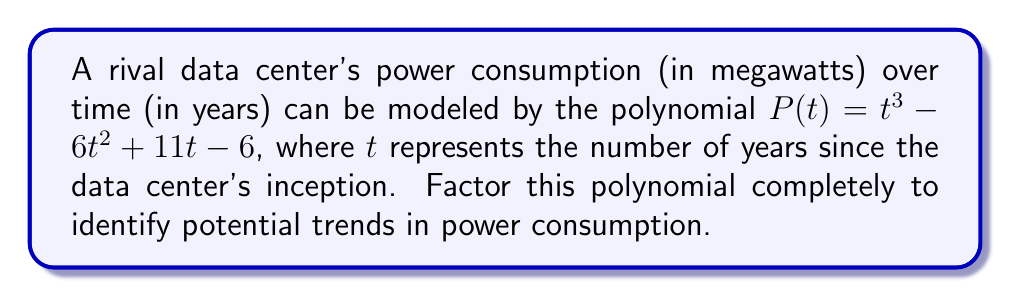Give your solution to this math problem. To factor this polynomial, we'll follow these steps:

1) First, let's check if there's a common factor. In this case, there isn't.

2) Next, we'll try to guess a rational root. The possible rational roots are the factors of the constant term: ±1, ±2, ±3, ±6.

3) Testing these values, we find that $P(1) = 0$. So $(t-1)$ is a factor.

4) We can use polynomial long division to divide $P(t)$ by $(t-1)$:

   $$t^3 - 6t^2 + 11t - 6 = (t-1)(t^2 - 5t + 6)$$

5) Now we need to factor the quadratic term $t^2 - 5t + 6$. We can do this by finding two numbers that multiply to give 6 and add to give -5. These numbers are -2 and -3.

6) Therefore, $t^2 - 5t + 6 = (t-2)(t-3)$

7) Combining all factors, we get:

   $$P(t) = (t-1)(t-2)(t-3)$$

This factorization reveals that the power consumption will be zero at years 1, 2, and 3, which could represent significant milestones in the data center's efficiency improvements.
Answer: $(t-1)(t-2)(t-3)$ 